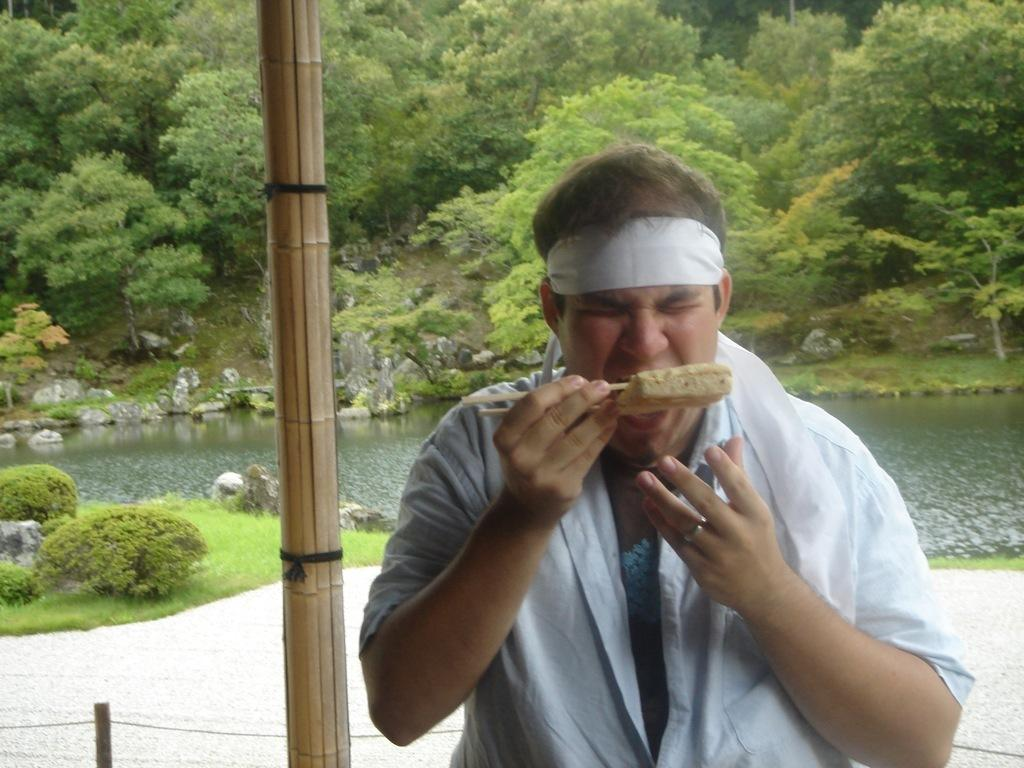Who is the main subject in the image? There is a person in the center of the image. What is the person doing in the image? The person is eating a food item using chopsticks. What can be seen in the background of the image? There are trees and water visible in the background. What type of apparel is the person wearing to perform addition in the image? There is no indication in the image that the person is performing addition or wearing any specific apparel for that purpose. 